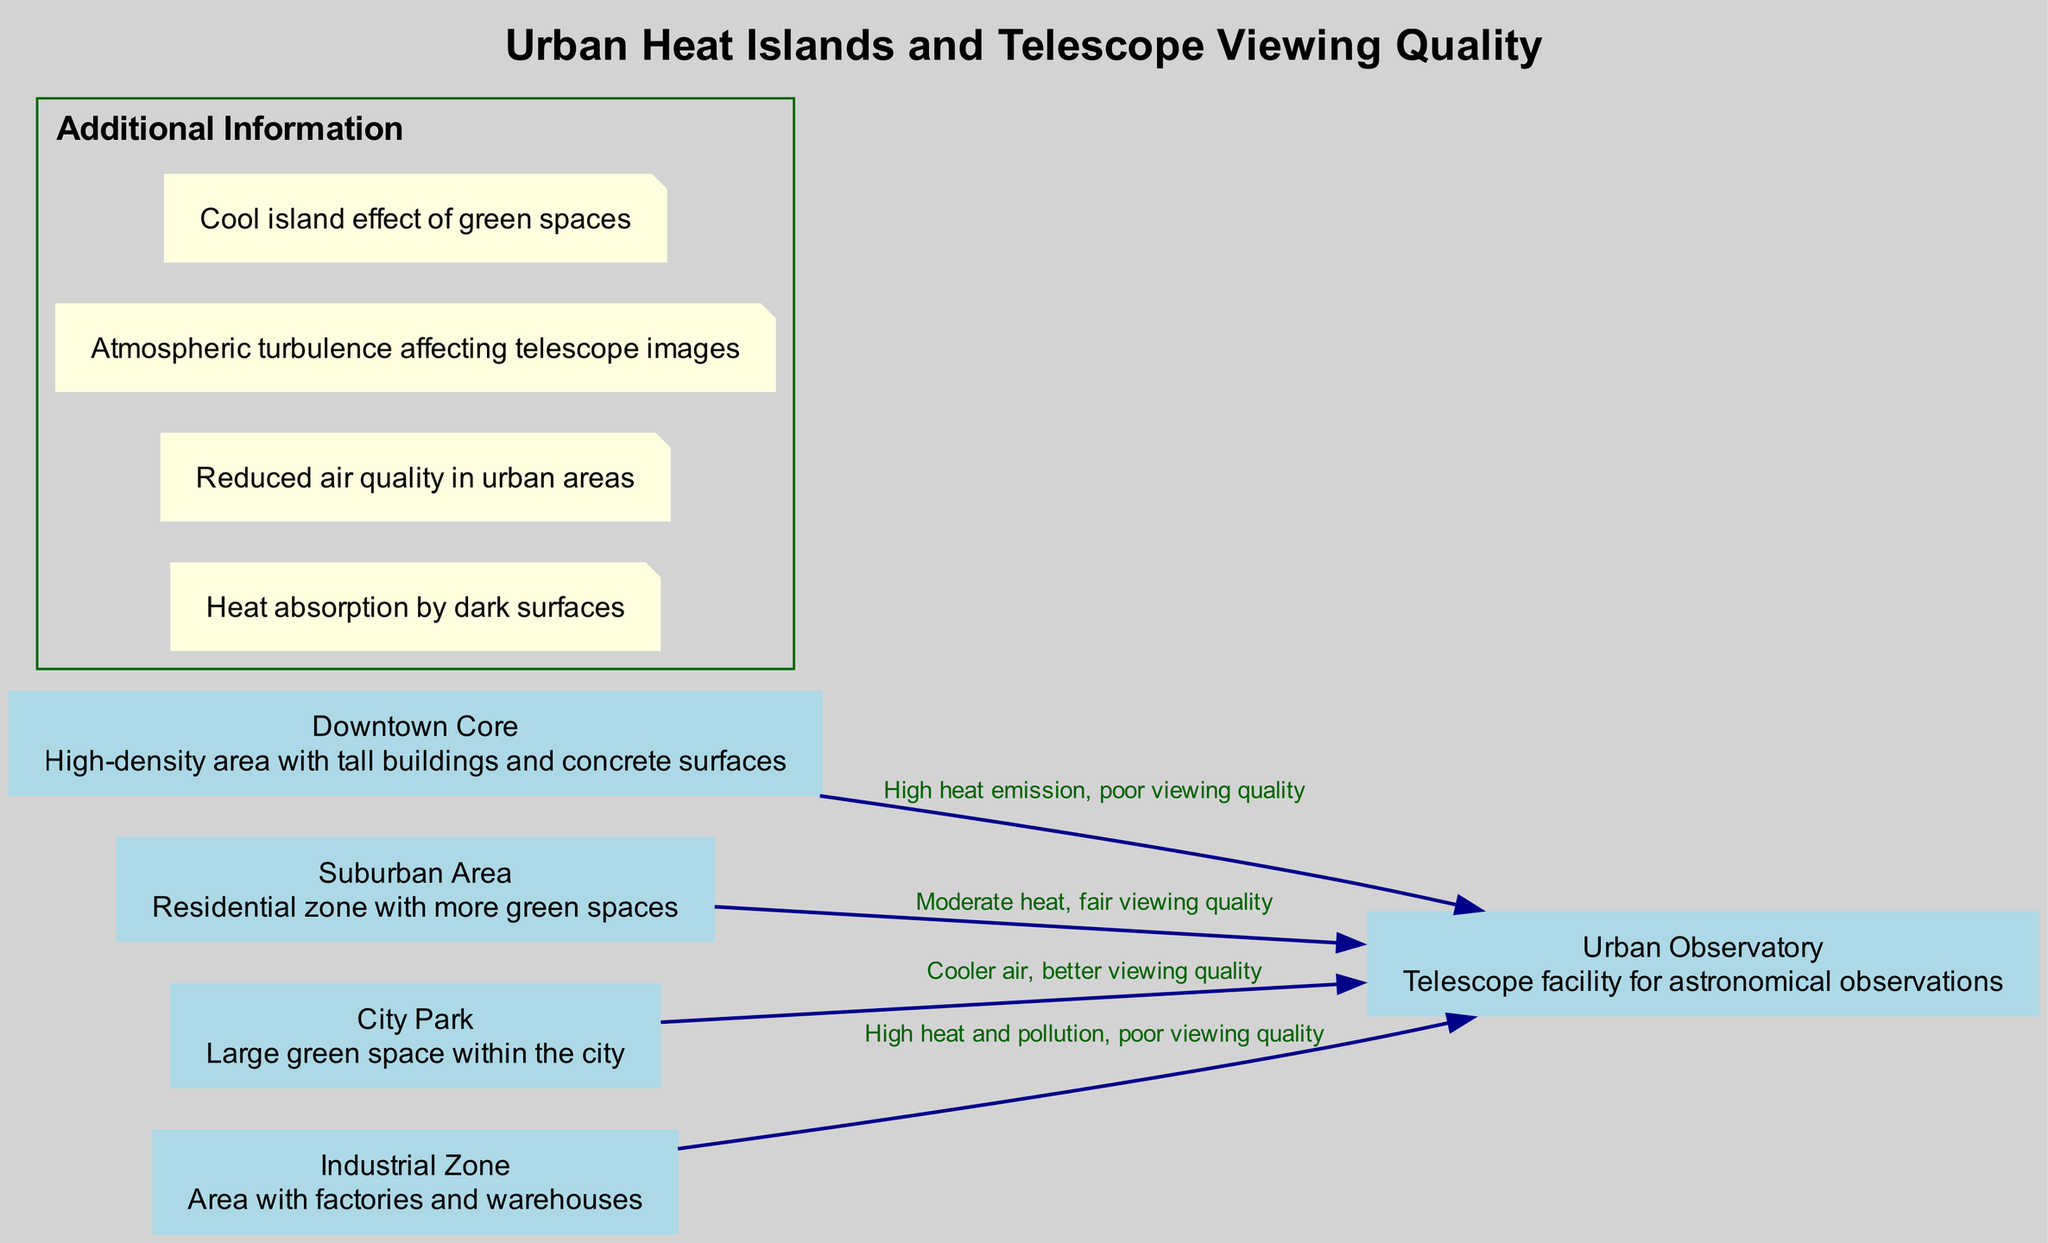What is the node representing the area with the best viewing quality? In the diagram, the node labeled "City Park" indicates that it provides cooler air, resulting in better viewing quality for the telescope.
Answer: City Park How many nodes are present in the diagram? The diagram contains a total of five nodes: Downtown Core, Suburban Area, City Park, Industrial Zone, and Urban Observatory.
Answer: Five What type of area is represented by the "Downtown Core"? The "Downtown Core" node describes it as a high-density area characterized by tall buildings and concrete surfaces, which contribute to heat emission.
Answer: High-density area What is the viewing quality from the "Industrial Zone"? The edge connecting the "Industrial Zone" to the "Urban Observatory" states that there is high heat and pollution, leading to poor viewing quality.
Answer: Poor viewing quality Which area contributes to a moderate heat environment? According to the diagram, the "Suburban Area" is associated with moderate heat, which results in fair viewing quality for the telescope.
Answer: Suburban Area What negative atmospheric effect is caused by urban heat islands? One of the additional notes on the diagram indicates that urban heat islands lead to reduced air quality in urban areas, impacting overall environmental conditions.
Answer: Reduced air quality Why is the "City Park" important for telescope viewing? The "City Park" has a cooling effect, as indicated in the additional information about the cool island effect of green spaces, which helps improve telescope viewing quality.
Answer: Cooler air Which node has the most adverse effect on telescope viewing? The "Downtown Core" node is associated with high heat emission, indicated in the edges as having poor viewing quality, making it the most detrimental to telescope observations.
Answer: Downtown Core 